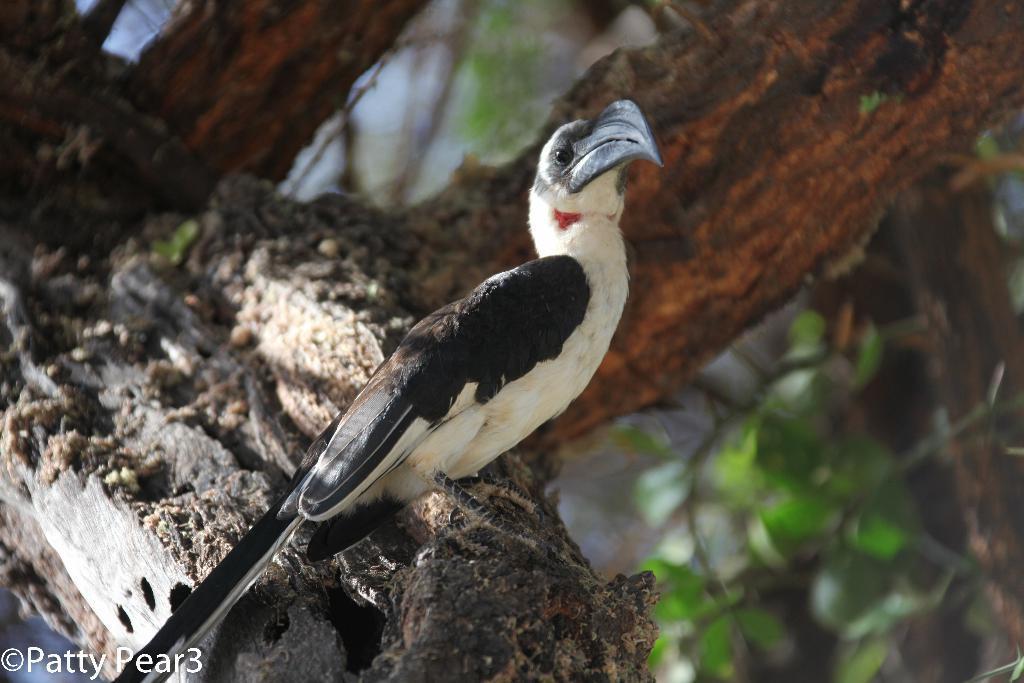Could you give a brief overview of what you see in this image? This is completely an outdoor picture. On the background of the picture we can see branch of a tree. In Front of the picture we can see a bird which is on the branch of a tree. 